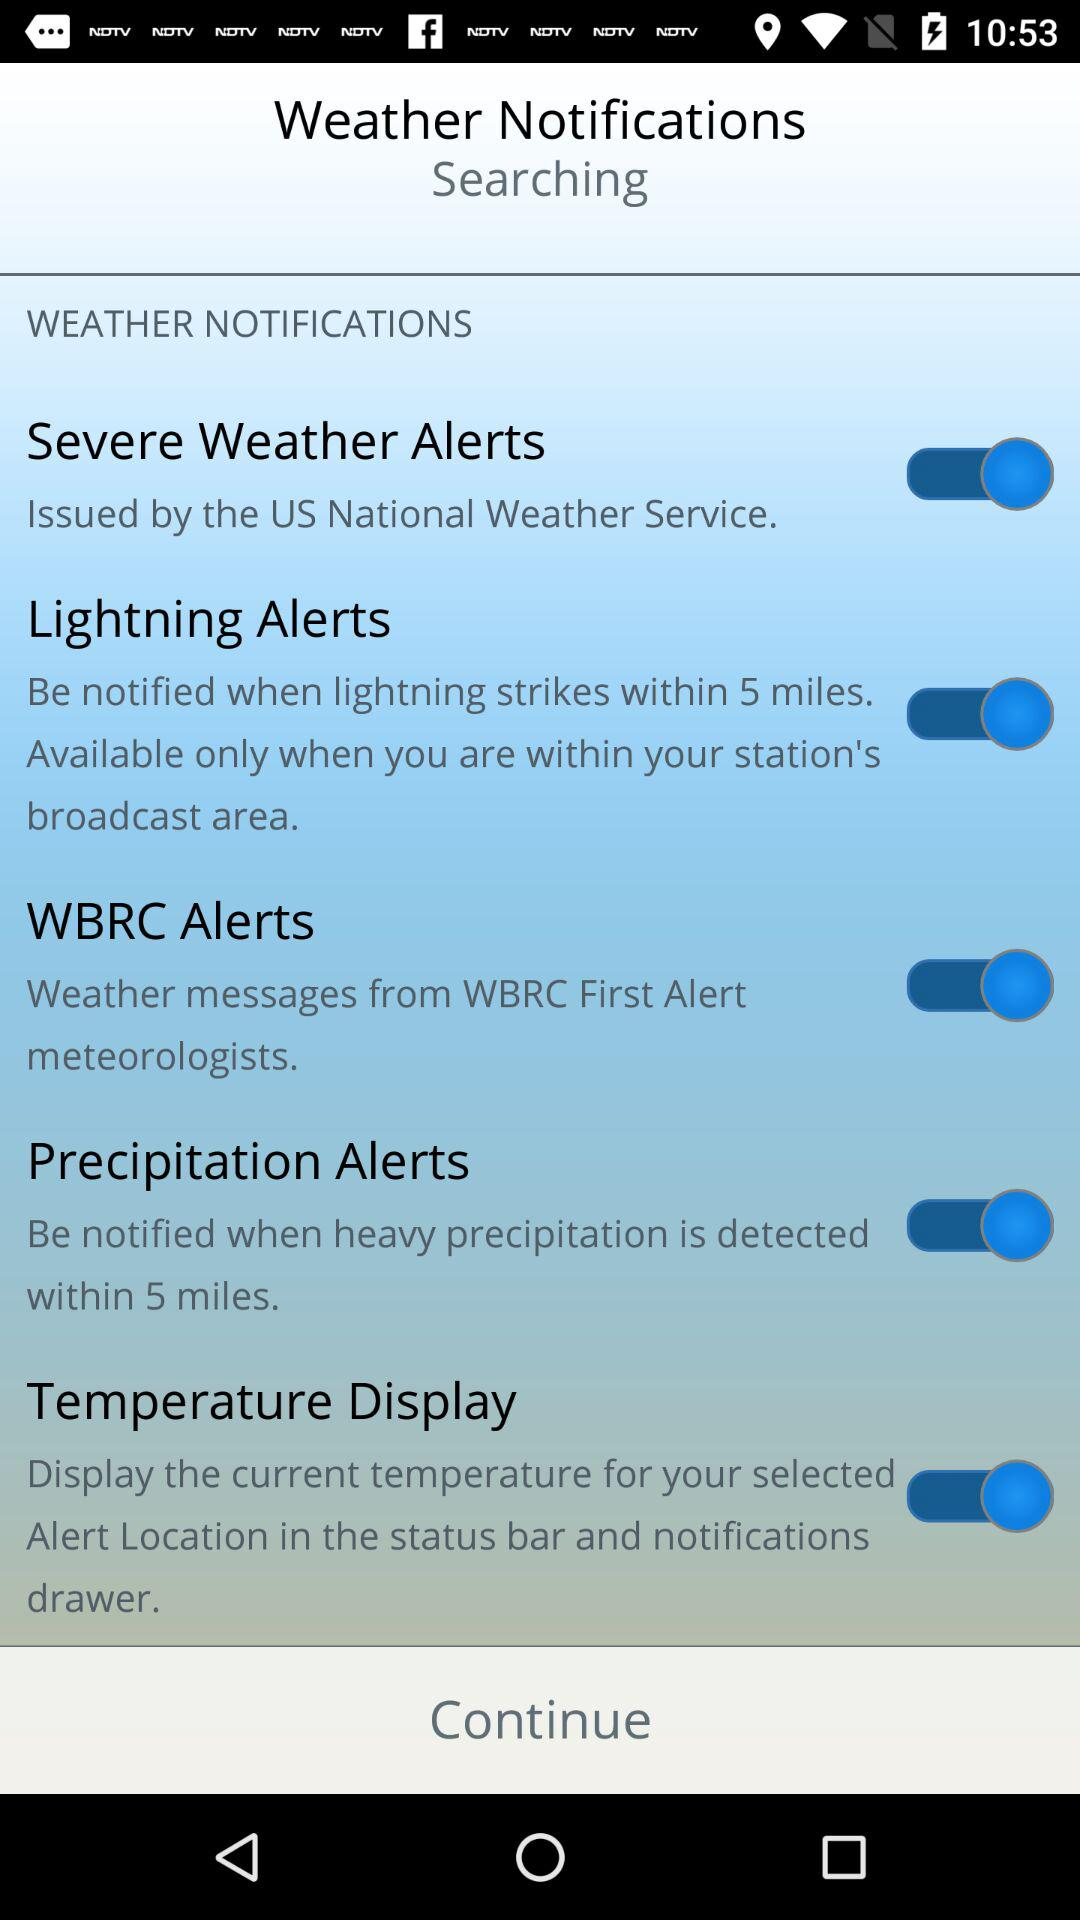What's the status of the "Temperature Display"? The status is on. 